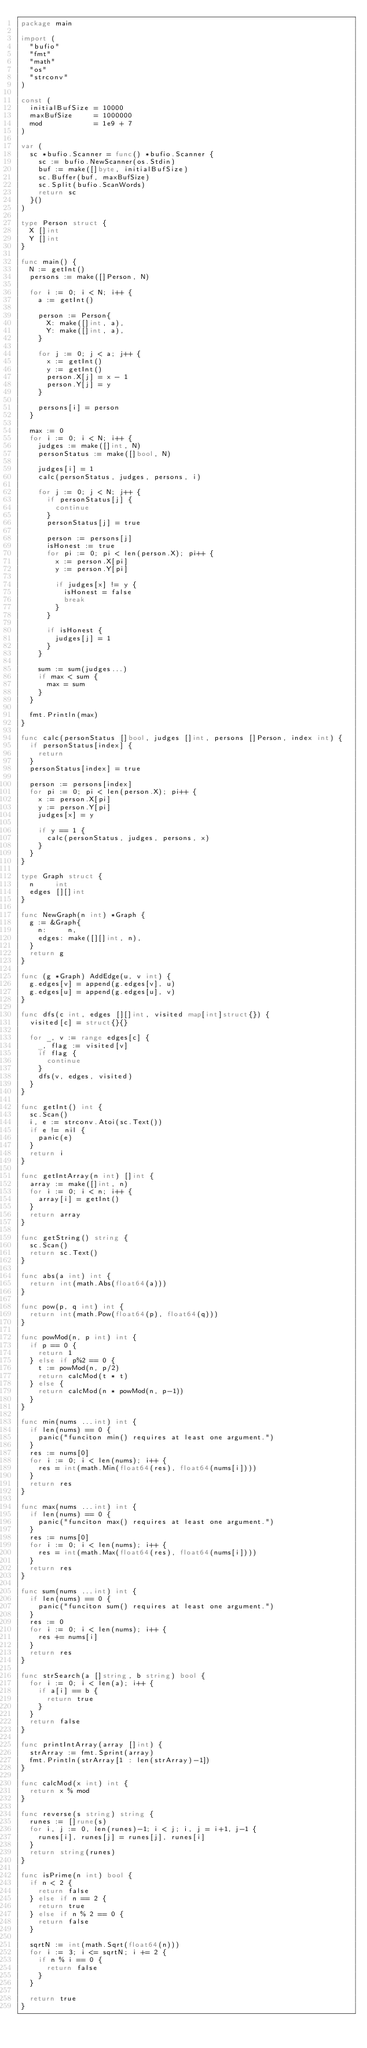<code> <loc_0><loc_0><loc_500><loc_500><_Go_>package main

import (
	"bufio"
	"fmt"
	"math"
	"os"
	"strconv"
)

const (
	initialBufSize = 10000
	maxBufSize     = 1000000
	mod            = 1e9 + 7
)

var (
	sc *bufio.Scanner = func() *bufio.Scanner {
		sc := bufio.NewScanner(os.Stdin)
		buf := make([]byte, initialBufSize)
		sc.Buffer(buf, maxBufSize)
		sc.Split(bufio.ScanWords)
		return sc
	}()
)

type Person struct {
	X []int
	Y []int
}

func main() {
	N := getInt()
	persons := make([]Person, N)

	for i := 0; i < N; i++ {
		a := getInt()

		person := Person{
			X: make([]int, a),
			Y: make([]int, a),
		}

		for j := 0; j < a; j++ {
			x := getInt()
			y := getInt()
			person.X[j] = x - 1
			person.Y[j] = y
		}

		persons[i] = person
	}

	max := 0
	for i := 0; i < N; i++ {
		judges := make([]int, N)
		personStatus := make([]bool, N)

		judges[i] = 1
		calc(personStatus, judges, persons, i)

		for j := 0; j < N; j++ {
			if personStatus[j] {
				continue
			}
			personStatus[j] = true

			person := persons[j]
			isHonest := true
			for pi := 0; pi < len(person.X); pi++ {
				x := person.X[pi]
				y := person.Y[pi]

				if judges[x] != y {
					isHonest = false
					break
				}
			}

			if isHonest {
				judges[j] = 1
			}
		}

		sum := sum(judges...)
		if max < sum {
			max = sum
		}
	}

	fmt.Println(max)
}

func calc(personStatus []bool, judges []int, persons []Person, index int) {
	if personStatus[index] {
		return
	}
	personStatus[index] = true

	person := persons[index]
	for pi := 0; pi < len(person.X); pi++ {
		x := person.X[pi]
		y := person.Y[pi]
		judges[x] = y

		if y == 1 {
			calc(personStatus, judges, persons, x)
		}
	}
}

type Graph struct {
	n     int
	edges [][]int
}

func NewGraph(n int) *Graph {
	g := &Graph{
		n:     n,
		edges: make([][]int, n),
	}
	return g
}

func (g *Graph) AddEdge(u, v int) {
	g.edges[v] = append(g.edges[v], u)
	g.edges[u] = append(g.edges[u], v)
}

func dfs(c int, edges [][]int, visited map[int]struct{}) {
	visited[c] = struct{}{}

	for _, v := range edges[c] {
		_, flag := visited[v]
		if flag {
			continue
		}
		dfs(v, edges, visited)
	}
}

func getInt() int {
	sc.Scan()
	i, e := strconv.Atoi(sc.Text())
	if e != nil {
		panic(e)
	}
	return i
}

func getIntArray(n int) []int {
	array := make([]int, n)
	for i := 0; i < n; i++ {
		array[i] = getInt()
	}
	return array
}

func getString() string {
	sc.Scan()
	return sc.Text()
}

func abs(a int) int {
	return int(math.Abs(float64(a)))
}

func pow(p, q int) int {
	return int(math.Pow(float64(p), float64(q)))
}

func powMod(n, p int) int {
	if p == 0 {
		return 1
	} else if p%2 == 0 {
		t := powMod(n, p/2)
		return calcMod(t * t)
	} else {
		return calcMod(n * powMod(n, p-1))
	}
}

func min(nums ...int) int {
	if len(nums) == 0 {
		panic("funciton min() requires at least one argument.")
	}
	res := nums[0]
	for i := 0; i < len(nums); i++ {
		res = int(math.Min(float64(res), float64(nums[i])))
	}
	return res
}

func max(nums ...int) int {
	if len(nums) == 0 {
		panic("funciton max() requires at least one argument.")
	}
	res := nums[0]
	for i := 0; i < len(nums); i++ {
		res = int(math.Max(float64(res), float64(nums[i])))
	}
	return res
}

func sum(nums ...int) int {
	if len(nums) == 0 {
		panic("funciton sum() requires at least one argument.")
	}
	res := 0
	for i := 0; i < len(nums); i++ {
		res += nums[i]
	}
	return res
}

func strSearch(a []string, b string) bool {
	for i := 0; i < len(a); i++ {
		if a[i] == b {
			return true
		}
	}
	return false
}

func printIntArray(array []int) {
	strArray := fmt.Sprint(array)
	fmt.Println(strArray[1 : len(strArray)-1])
}

func calcMod(x int) int {
	return x % mod
}

func reverse(s string) string {
	runes := []rune(s)
	for i, j := 0, len(runes)-1; i < j; i, j = i+1, j-1 {
		runes[i], runes[j] = runes[j], runes[i]
	}
	return string(runes)
}

func isPrime(n int) bool {
	if n < 2 {
		return false
	} else if n == 2 {
		return true
	} else if n % 2 == 0 {
		return false
	}

	sqrtN := int(math.Sqrt(float64(n)))
	for i := 3; i <= sqrtN; i += 2 {
		if n % i == 0 {
			return false
		}
	}

	return true
}
</code> 